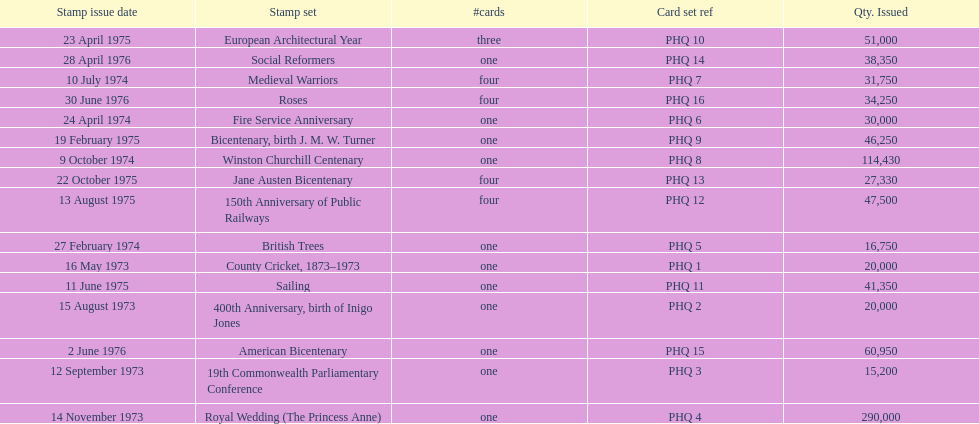How many stamp sets had at least 50,000 issued? 4. 